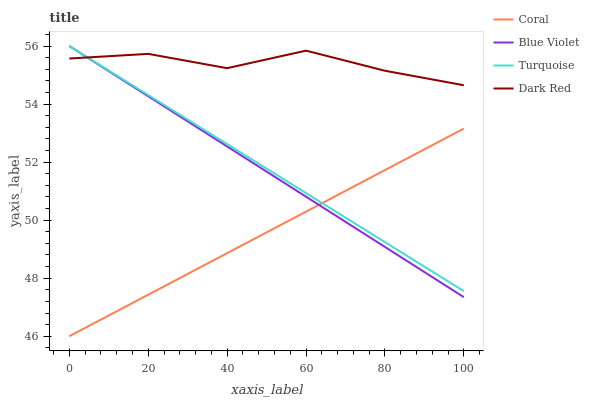Does Coral have the minimum area under the curve?
Answer yes or no. Yes. Does Dark Red have the maximum area under the curve?
Answer yes or no. Yes. Does Turquoise have the minimum area under the curve?
Answer yes or no. No. Does Turquoise have the maximum area under the curve?
Answer yes or no. No. Is Coral the smoothest?
Answer yes or no. Yes. Is Dark Red the roughest?
Answer yes or no. Yes. Is Turquoise the smoothest?
Answer yes or no. No. Is Turquoise the roughest?
Answer yes or no. No. Does Coral have the lowest value?
Answer yes or no. Yes. Does Turquoise have the lowest value?
Answer yes or no. No. Does Blue Violet have the highest value?
Answer yes or no. Yes. Does Coral have the highest value?
Answer yes or no. No. Is Coral less than Dark Red?
Answer yes or no. Yes. Is Dark Red greater than Coral?
Answer yes or no. Yes. Does Dark Red intersect Turquoise?
Answer yes or no. Yes. Is Dark Red less than Turquoise?
Answer yes or no. No. Is Dark Red greater than Turquoise?
Answer yes or no. No. Does Coral intersect Dark Red?
Answer yes or no. No. 